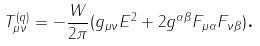Convert formula to latex. <formula><loc_0><loc_0><loc_500><loc_500>T _ { \mu \nu } ^ { ( q ) } = - \frac { W } { 2 \pi } ( g _ { \mu \nu } E ^ { 2 } + 2 g ^ { \alpha \beta } F _ { \mu \alpha } F _ { \nu \beta } ) \text {.}</formula> 